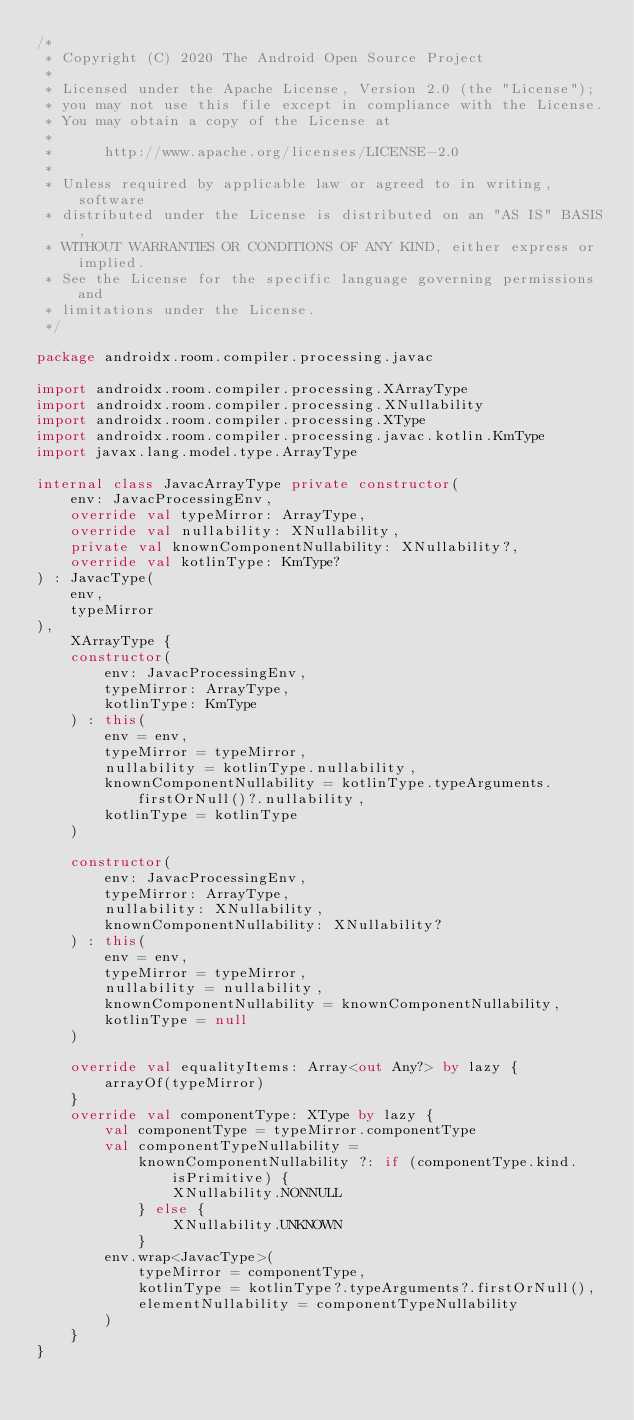<code> <loc_0><loc_0><loc_500><loc_500><_Kotlin_>/*
 * Copyright (C) 2020 The Android Open Source Project
 *
 * Licensed under the Apache License, Version 2.0 (the "License");
 * you may not use this file except in compliance with the License.
 * You may obtain a copy of the License at
 *
 *      http://www.apache.org/licenses/LICENSE-2.0
 *
 * Unless required by applicable law or agreed to in writing, software
 * distributed under the License is distributed on an "AS IS" BASIS,
 * WITHOUT WARRANTIES OR CONDITIONS OF ANY KIND, either express or implied.
 * See the License for the specific language governing permissions and
 * limitations under the License.
 */

package androidx.room.compiler.processing.javac

import androidx.room.compiler.processing.XArrayType
import androidx.room.compiler.processing.XNullability
import androidx.room.compiler.processing.XType
import androidx.room.compiler.processing.javac.kotlin.KmType
import javax.lang.model.type.ArrayType

internal class JavacArrayType private constructor(
    env: JavacProcessingEnv,
    override val typeMirror: ArrayType,
    override val nullability: XNullability,
    private val knownComponentNullability: XNullability?,
    override val kotlinType: KmType?
) : JavacType(
    env,
    typeMirror
),
    XArrayType {
    constructor(
        env: JavacProcessingEnv,
        typeMirror: ArrayType,
        kotlinType: KmType
    ) : this(
        env = env,
        typeMirror = typeMirror,
        nullability = kotlinType.nullability,
        knownComponentNullability = kotlinType.typeArguments.firstOrNull()?.nullability,
        kotlinType = kotlinType
    )

    constructor(
        env: JavacProcessingEnv,
        typeMirror: ArrayType,
        nullability: XNullability,
        knownComponentNullability: XNullability?
    ) : this(
        env = env,
        typeMirror = typeMirror,
        nullability = nullability,
        knownComponentNullability = knownComponentNullability,
        kotlinType = null
    )

    override val equalityItems: Array<out Any?> by lazy {
        arrayOf(typeMirror)
    }
    override val componentType: XType by lazy {
        val componentType = typeMirror.componentType
        val componentTypeNullability =
            knownComponentNullability ?: if (componentType.kind.isPrimitive) {
                XNullability.NONNULL
            } else {
                XNullability.UNKNOWN
            }
        env.wrap<JavacType>(
            typeMirror = componentType,
            kotlinType = kotlinType?.typeArguments?.firstOrNull(),
            elementNullability = componentTypeNullability
        )
    }
}</code> 